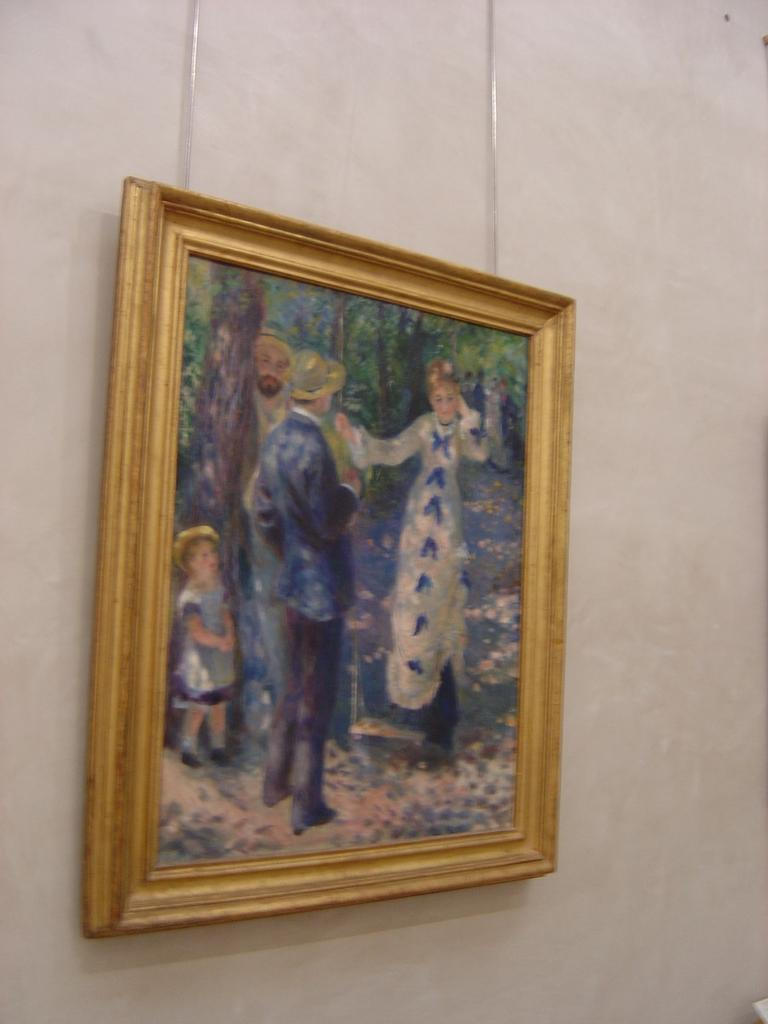What is attached to the wall in the image? There is a frame attached to the wall in the image. What can be seen within the frame? There are people standing in the frame. What type of natural scenery is visible within the frame? There are trees visible within the frame. How many boys are sitting on the committee in the image? There is no committee or boys present in the image; it features a frame with people standing in it and trees visible in the background. 